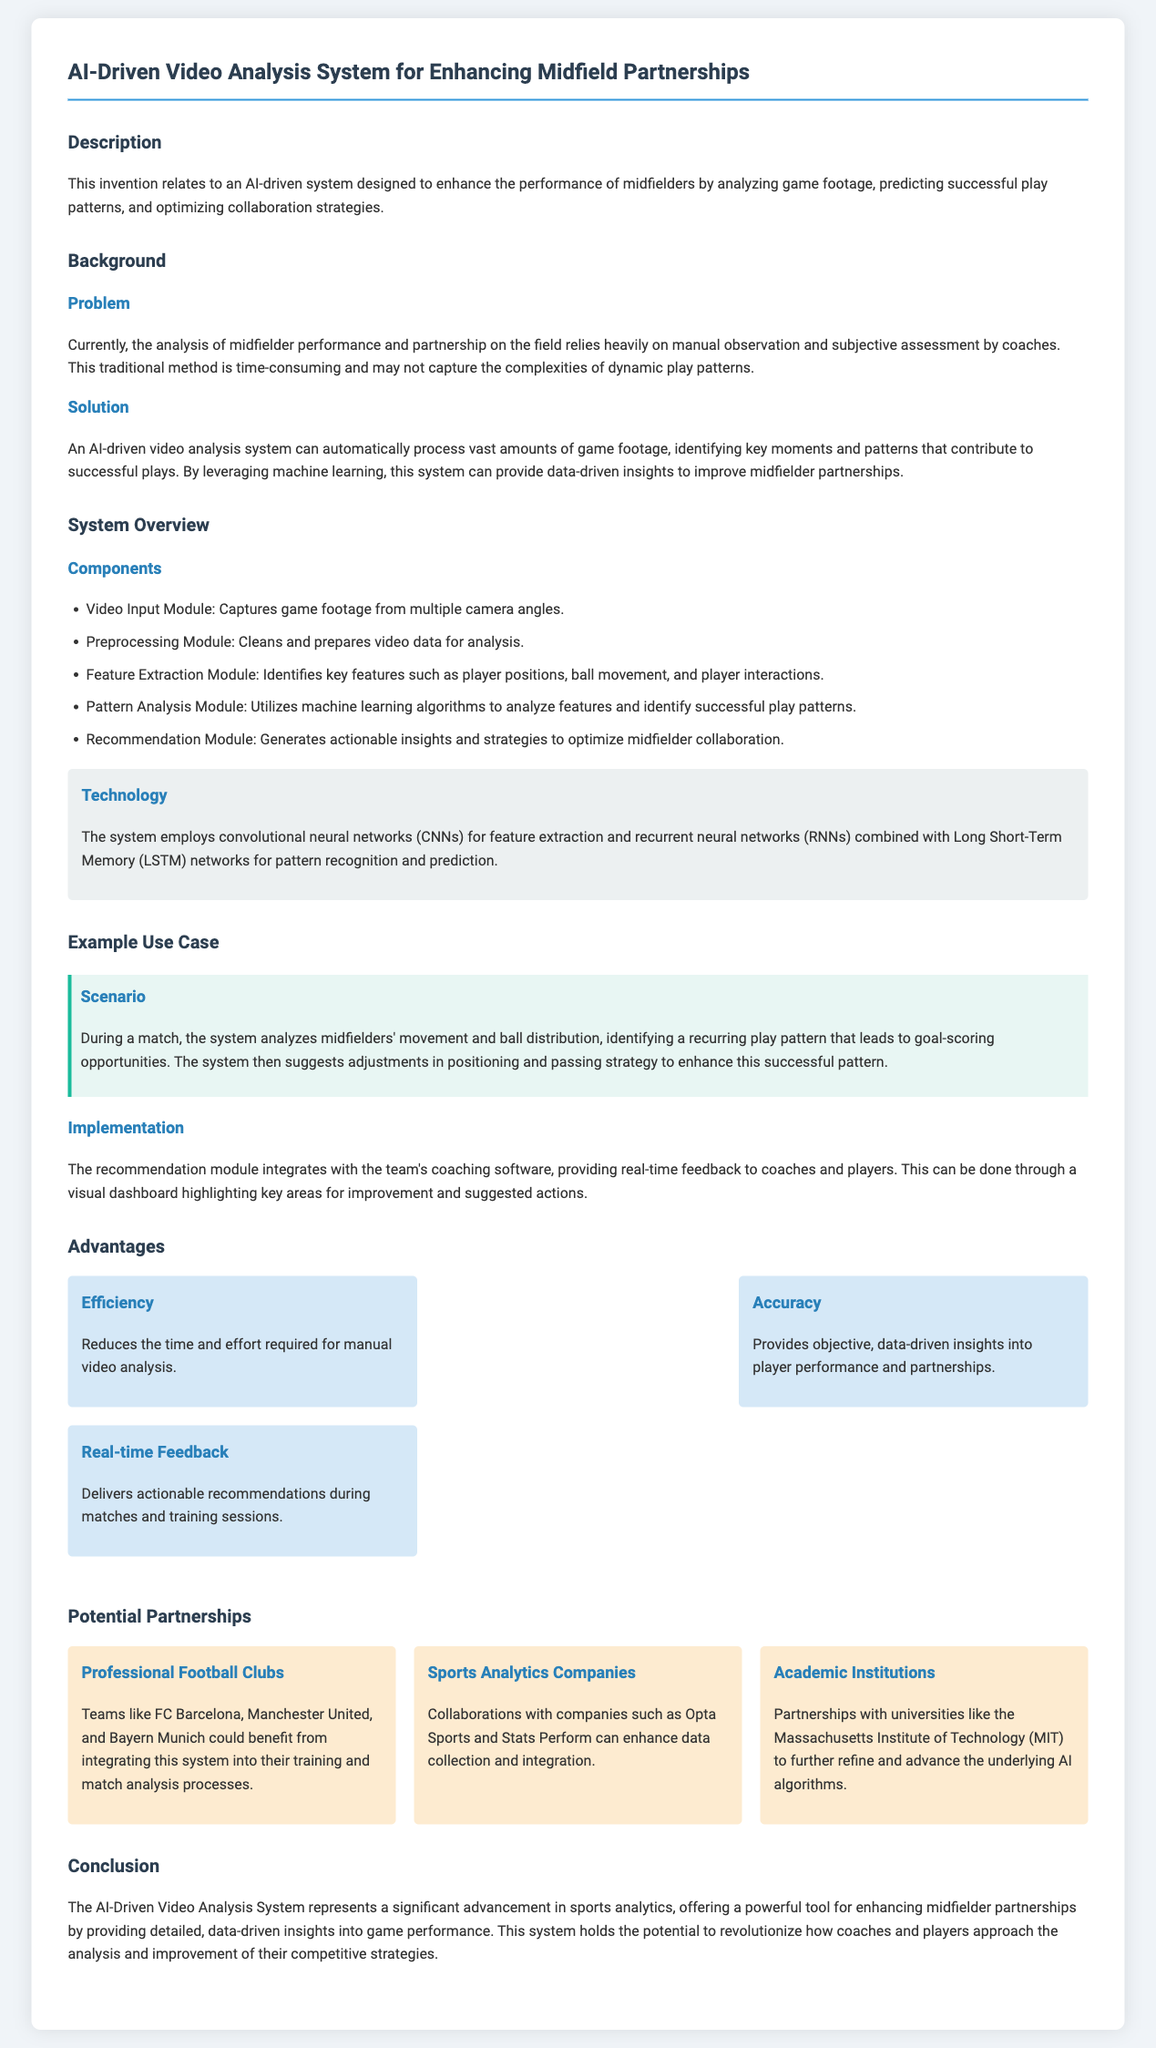what is the title of the patent application? The title is clearly stated at the beginning of the document.
Answer: AI-Driven Video Analysis System for Enhancing Midfield Partnerships what technology does the system employ for feature extraction? The document specifies the technology used in the feature extraction module of the system.
Answer: Convolutional neural networks (CNNs) who are the potential partners mentioned for this system? The document lists several potential partnerships in a dedicated section.
Answer: Professional Football Clubs, Sports Analytics Companies, Academic Institutions what is the main problem addressed by the system? The problem is described in the background section of the document, focusing on current methods of analysis.
Answer: Manual observation and subjective assessment how does the system provide feedback during matches? The implementation section describes the functionality of the recommendation module.
Answer: Real-time feedback what is one of the advantages of using this AI-driven system? The advantages of the system are enumerated in a section specifically addressing them.
Answer: Efficiency how does the system analyze game footage? The document outlines the method of analysis within the system overview section.
Answer: Utilizing machine learning algorithms which academic institution is mentioned for potential partnerships? The document lists specific institutions that could collaborate with them.
Answer: Massachusetts Institute of Technology (MIT) what type of modules does the system consist of? The system overview section describes various components of the system.
Answer: Video Input Module, Preprocessing Module, Feature Extraction Module, Pattern Analysis Module, Recommendation Module 